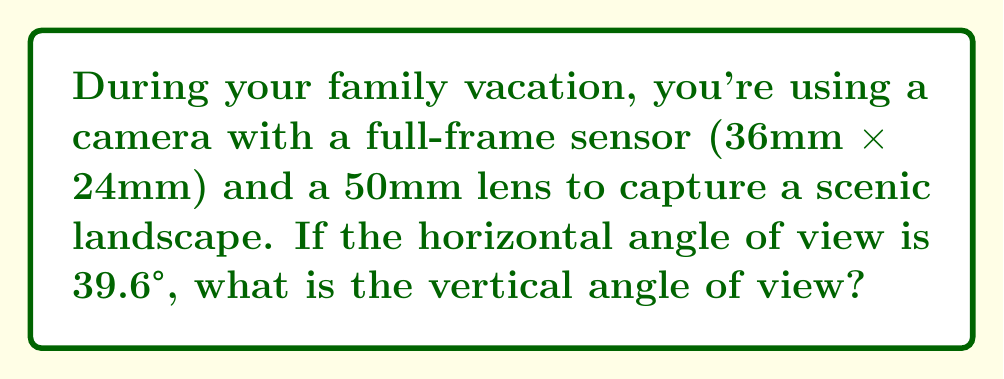Help me with this question. To solve this problem, we'll use the relationship between focal length, sensor size, and angle of view. The formula for angle of view is:

$$\text{Angle of View} = 2 \arctan\left(\frac{\text{Sensor Dimension}}{2f}\right)$$

Where $f$ is the focal length.

Given:
- Horizontal angle of view: 39.6°
- Focal length: 50mm
- Sensor dimensions: 36mm x 24mm

Step 1: Verify the horizontal angle of view
$$39.6° = 2 \arctan\left(\frac{36}{2 \cdot 50}\right)$$
This checks out.

Step 2: Calculate the vertical angle of view using the same formula
$$\text{Vertical Angle} = 2 \arctan\left(\frac{24}{2 \cdot 50}\right)$$

Step 3: Solve the equation
$$\text{Vertical Angle} = 2 \arctan\left(\frac{12}{50}\right)$$
$$\text{Vertical Angle} = 2 \arctan(0.24)$$
$$\text{Vertical Angle} = 2 \cdot 13.496°$$
$$\text{Vertical Angle} = 26.992°$$

Therefore, the vertical angle of view is approximately 27°.
Answer: 27° 